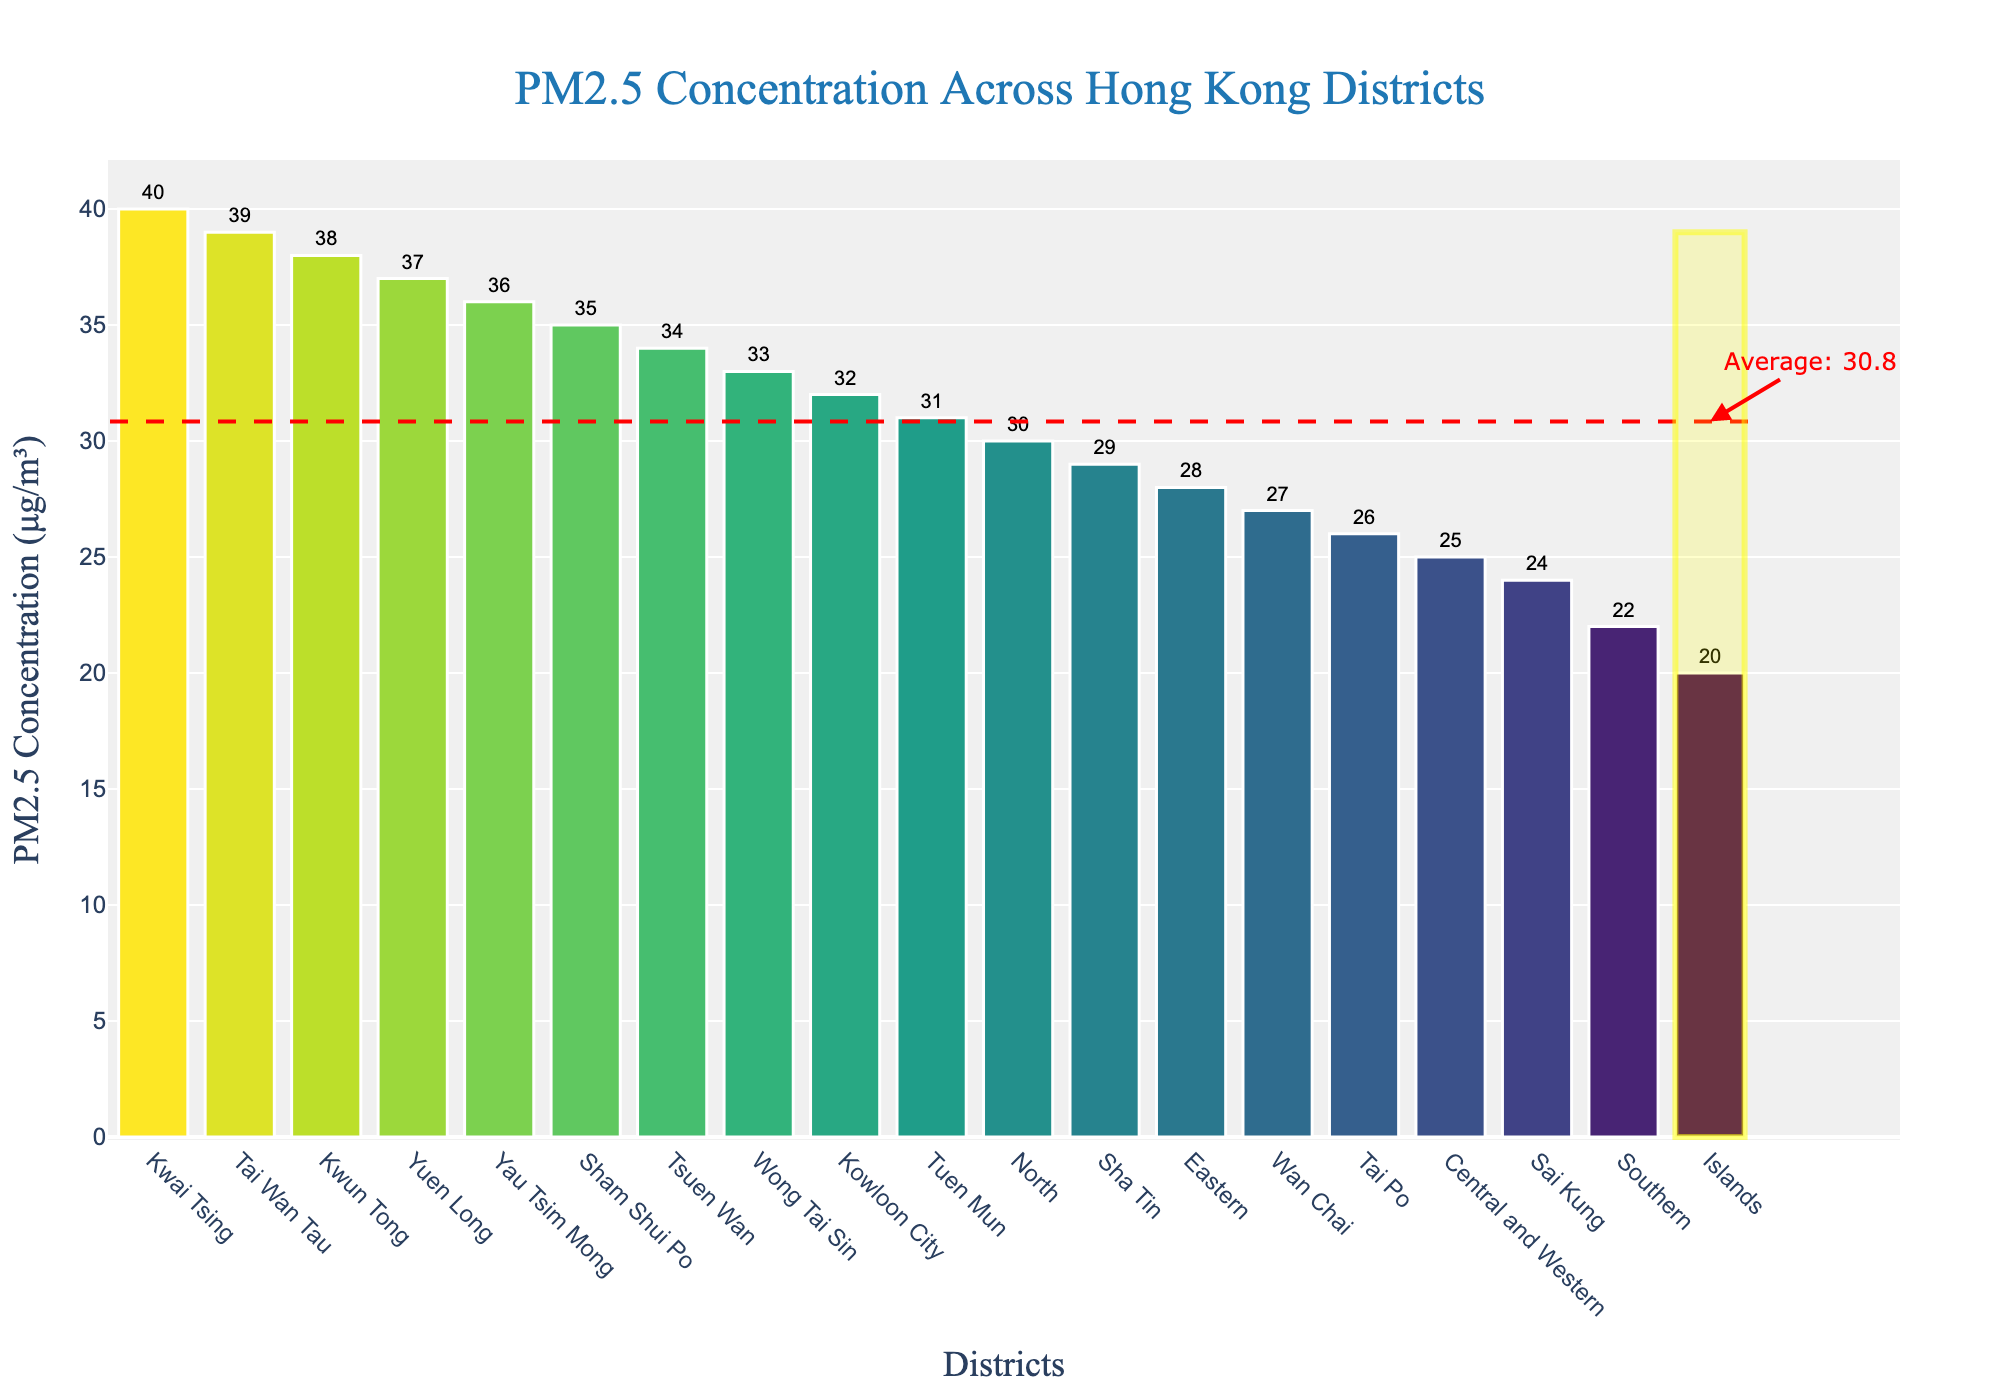Which district has the highest PM2.5 concentration? By looking at the figure, the bar representing Kwai Tsing reaches the highest point on the y-axis, indicating it has the highest PM2.5 concentration value of 40 μg/m³.
Answer: Kwai Tsing Which district has the lowest PM2.5 concentration? The bar for Islands district is the shortest, indicating it has the lowest PM2.5 concentration, which is 20 μg/m³.
Answer: Islands What is the average PM2.5 concentration across all districts? A red dashed horizontal line marks the average PM2.5 concentration value, which is labeled with a text indicating the value. This value is approximately 30.5 μg/m³.
Answer: 30.5 How does Tai Wan Tau's PM2.5 concentration compare to the average concentration? Tai Wan Tau's PM2.5 concentration is 39 μg/m³, which is highlighted. The average concentration is about 30.5 μg/m³, so Tai Wan Tau's value is higher than the average.
Answer: Higher Which districts have a PM2.5 concentration greater than 35 μg/m³? The districts with bars exceeding the y-value of 35 μg/m³ are Kwai Tsing, Yuen Long, Tai Wan Tau, Yau Tsim Mong, Sham Shui Po.
Answer: Kwai Tsing, Yuen Long, Tai Wan Tau, Yau Tsim Mong, Sham Shui Po How many districts have a PM2.5 concentration below 25 μg/m³? By counting the bars that end below the 25 μg/m³ line, we see that there are three districts: Southern, Islands, and Sai Kung.
Answer: 3 Does Wan Chai have a higher or lower PM2.5 concentration than Sha Tin? Wan Chai’s PM2.5 concentration is 27 μg/m³, and Sha Tin’s is 29 μg/m³. Since 27 is less than 29, Wan Chai has a lower concentration than Sha Tin.
Answer: Lower What is the PM2.5 concentration difference between Kwun Tong and Central and Western? The bar for Kwun Tong shows a concentration of 38 μg/m³ and for Central and Western, it shows 25 μg/m³. The difference is calculated as 38 - 25 = 13 μg/m³.
Answer: 13 Which districts have a PM2.5 concentration exactly at the average value? Reviewing the figure, there is no bar that precisely aligns with the average value line, indicating no district has a PM2.5 concentration exactly at the average.
Answer: None Between Tsuen Wan and Kowloon City, which district has a higher PM2.5 concentration? The bar for Tsuen Wan shows 34 μg/m³ while for Kowloon City it shows 32 μg/m³. Therefore, Tsuen Wan has a higher PM2.5 concentration.
Answer: Tsuen Wan 